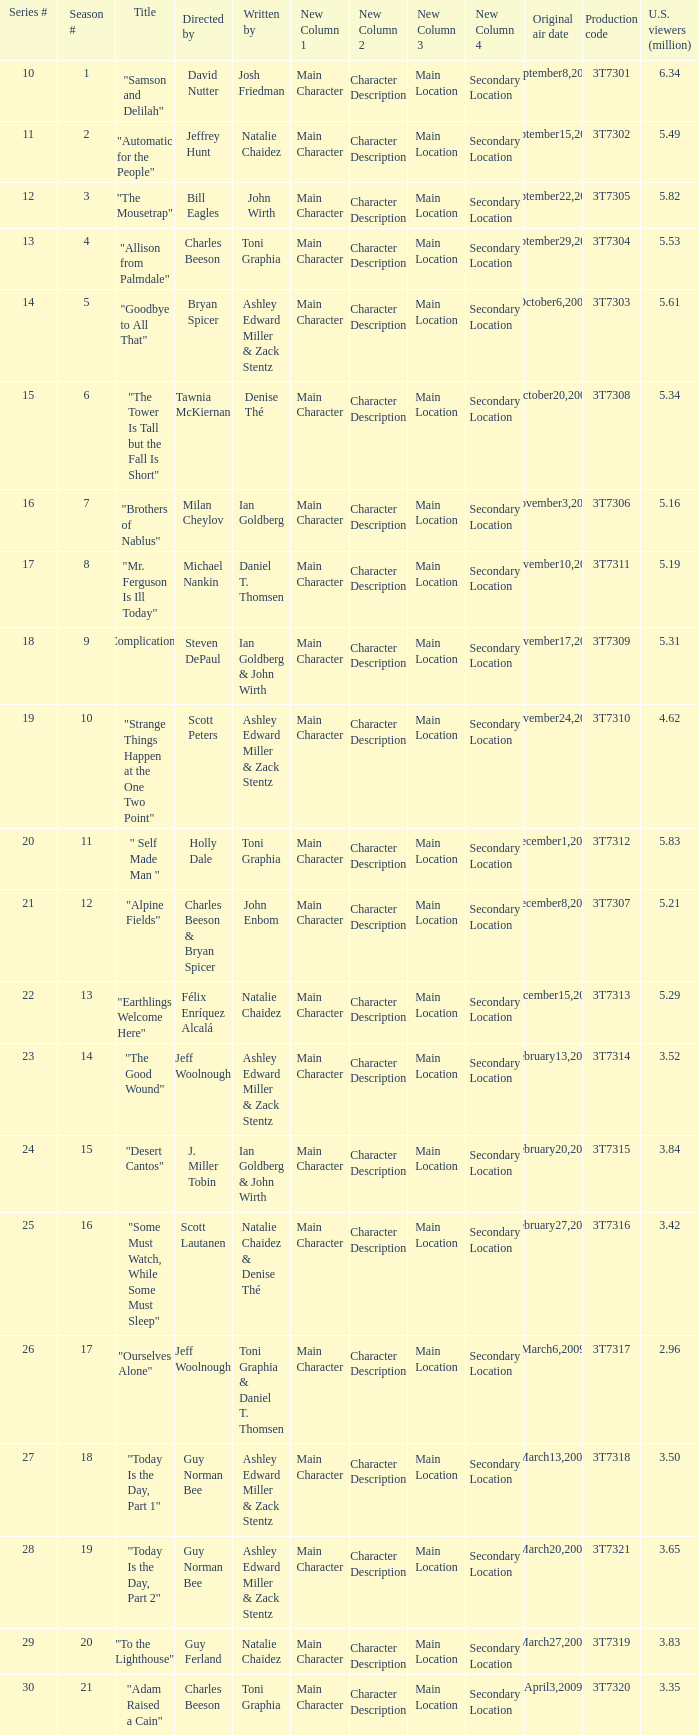Which episode number was directed by Bill Eagles? 12.0. 